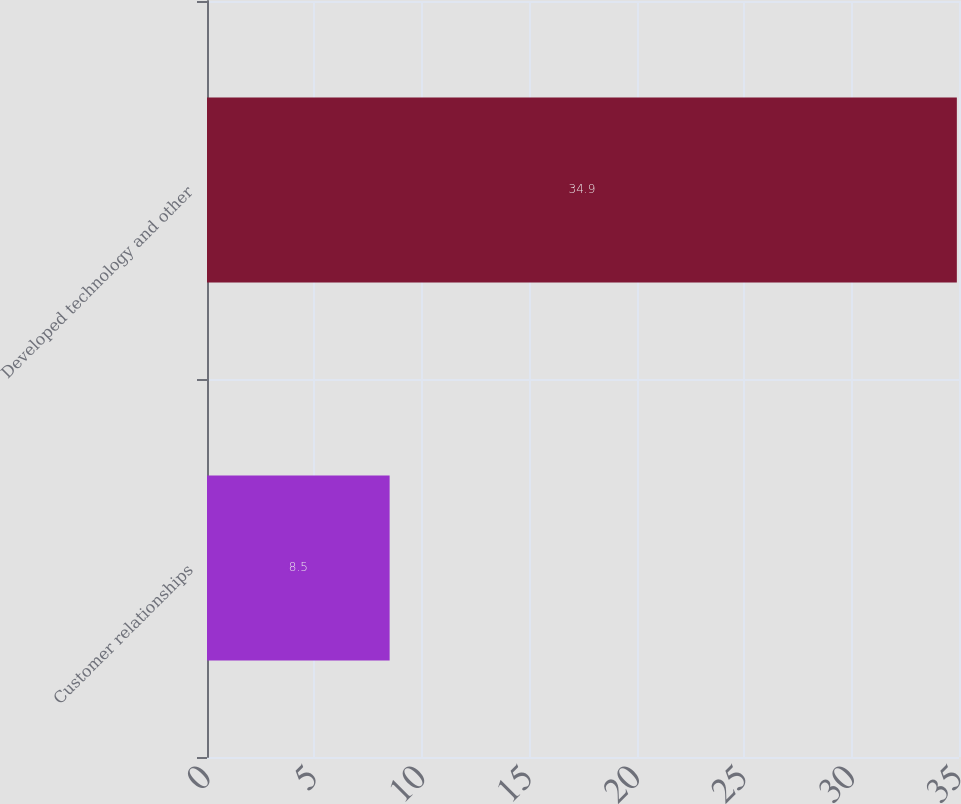Convert chart to OTSL. <chart><loc_0><loc_0><loc_500><loc_500><bar_chart><fcel>Customer relationships<fcel>Developed technology and other<nl><fcel>8.5<fcel>34.9<nl></chart> 